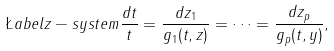<formula> <loc_0><loc_0><loc_500><loc_500>\L a b e l { z - s y s t e m } \frac { d t } { t } = \frac { d z _ { 1 } } { g _ { 1 } ( t , z ) } = \dots = \frac { d z _ { p } } { g _ { p } ( t , y ) } ,</formula> 